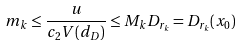<formula> <loc_0><loc_0><loc_500><loc_500>m _ { k } \leq \frac { u } { c _ { 2 } V ( d _ { D } ) } \leq M _ { k } D _ { r _ { k } } = D _ { r _ { k } } ( x _ { 0 } )</formula> 